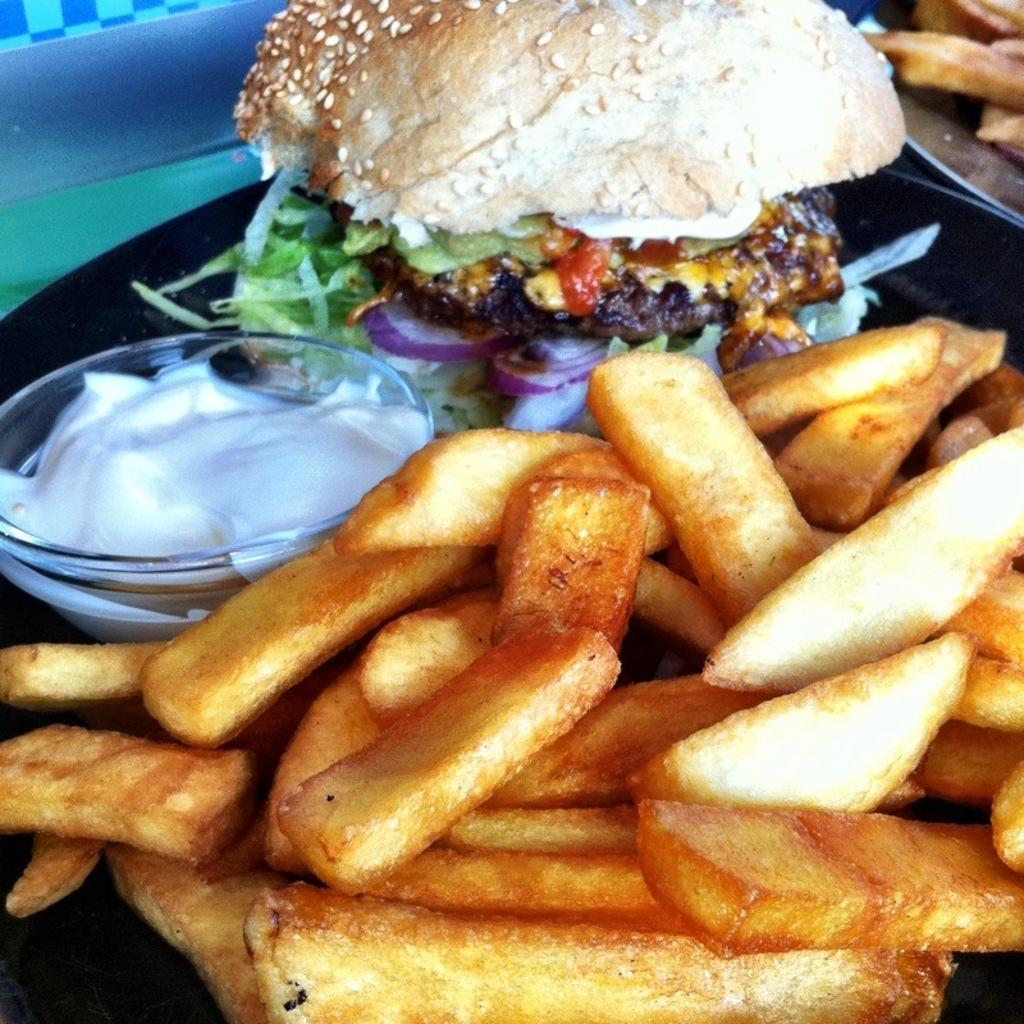What type of food is present in the image? There are french fries and a burger in the image. What is the cream in the image contained in? The cream is in a bowl in the image. How are the food items arranged in the image? All the food items are on a plate. What can be seen in the top right corner of the image? There is another food item on a plate in the top right corner of the image. How many ducks are swimming in the cream in the image? There are no ducks present in the image, and the cream is not a body of water for ducks to swim in. 